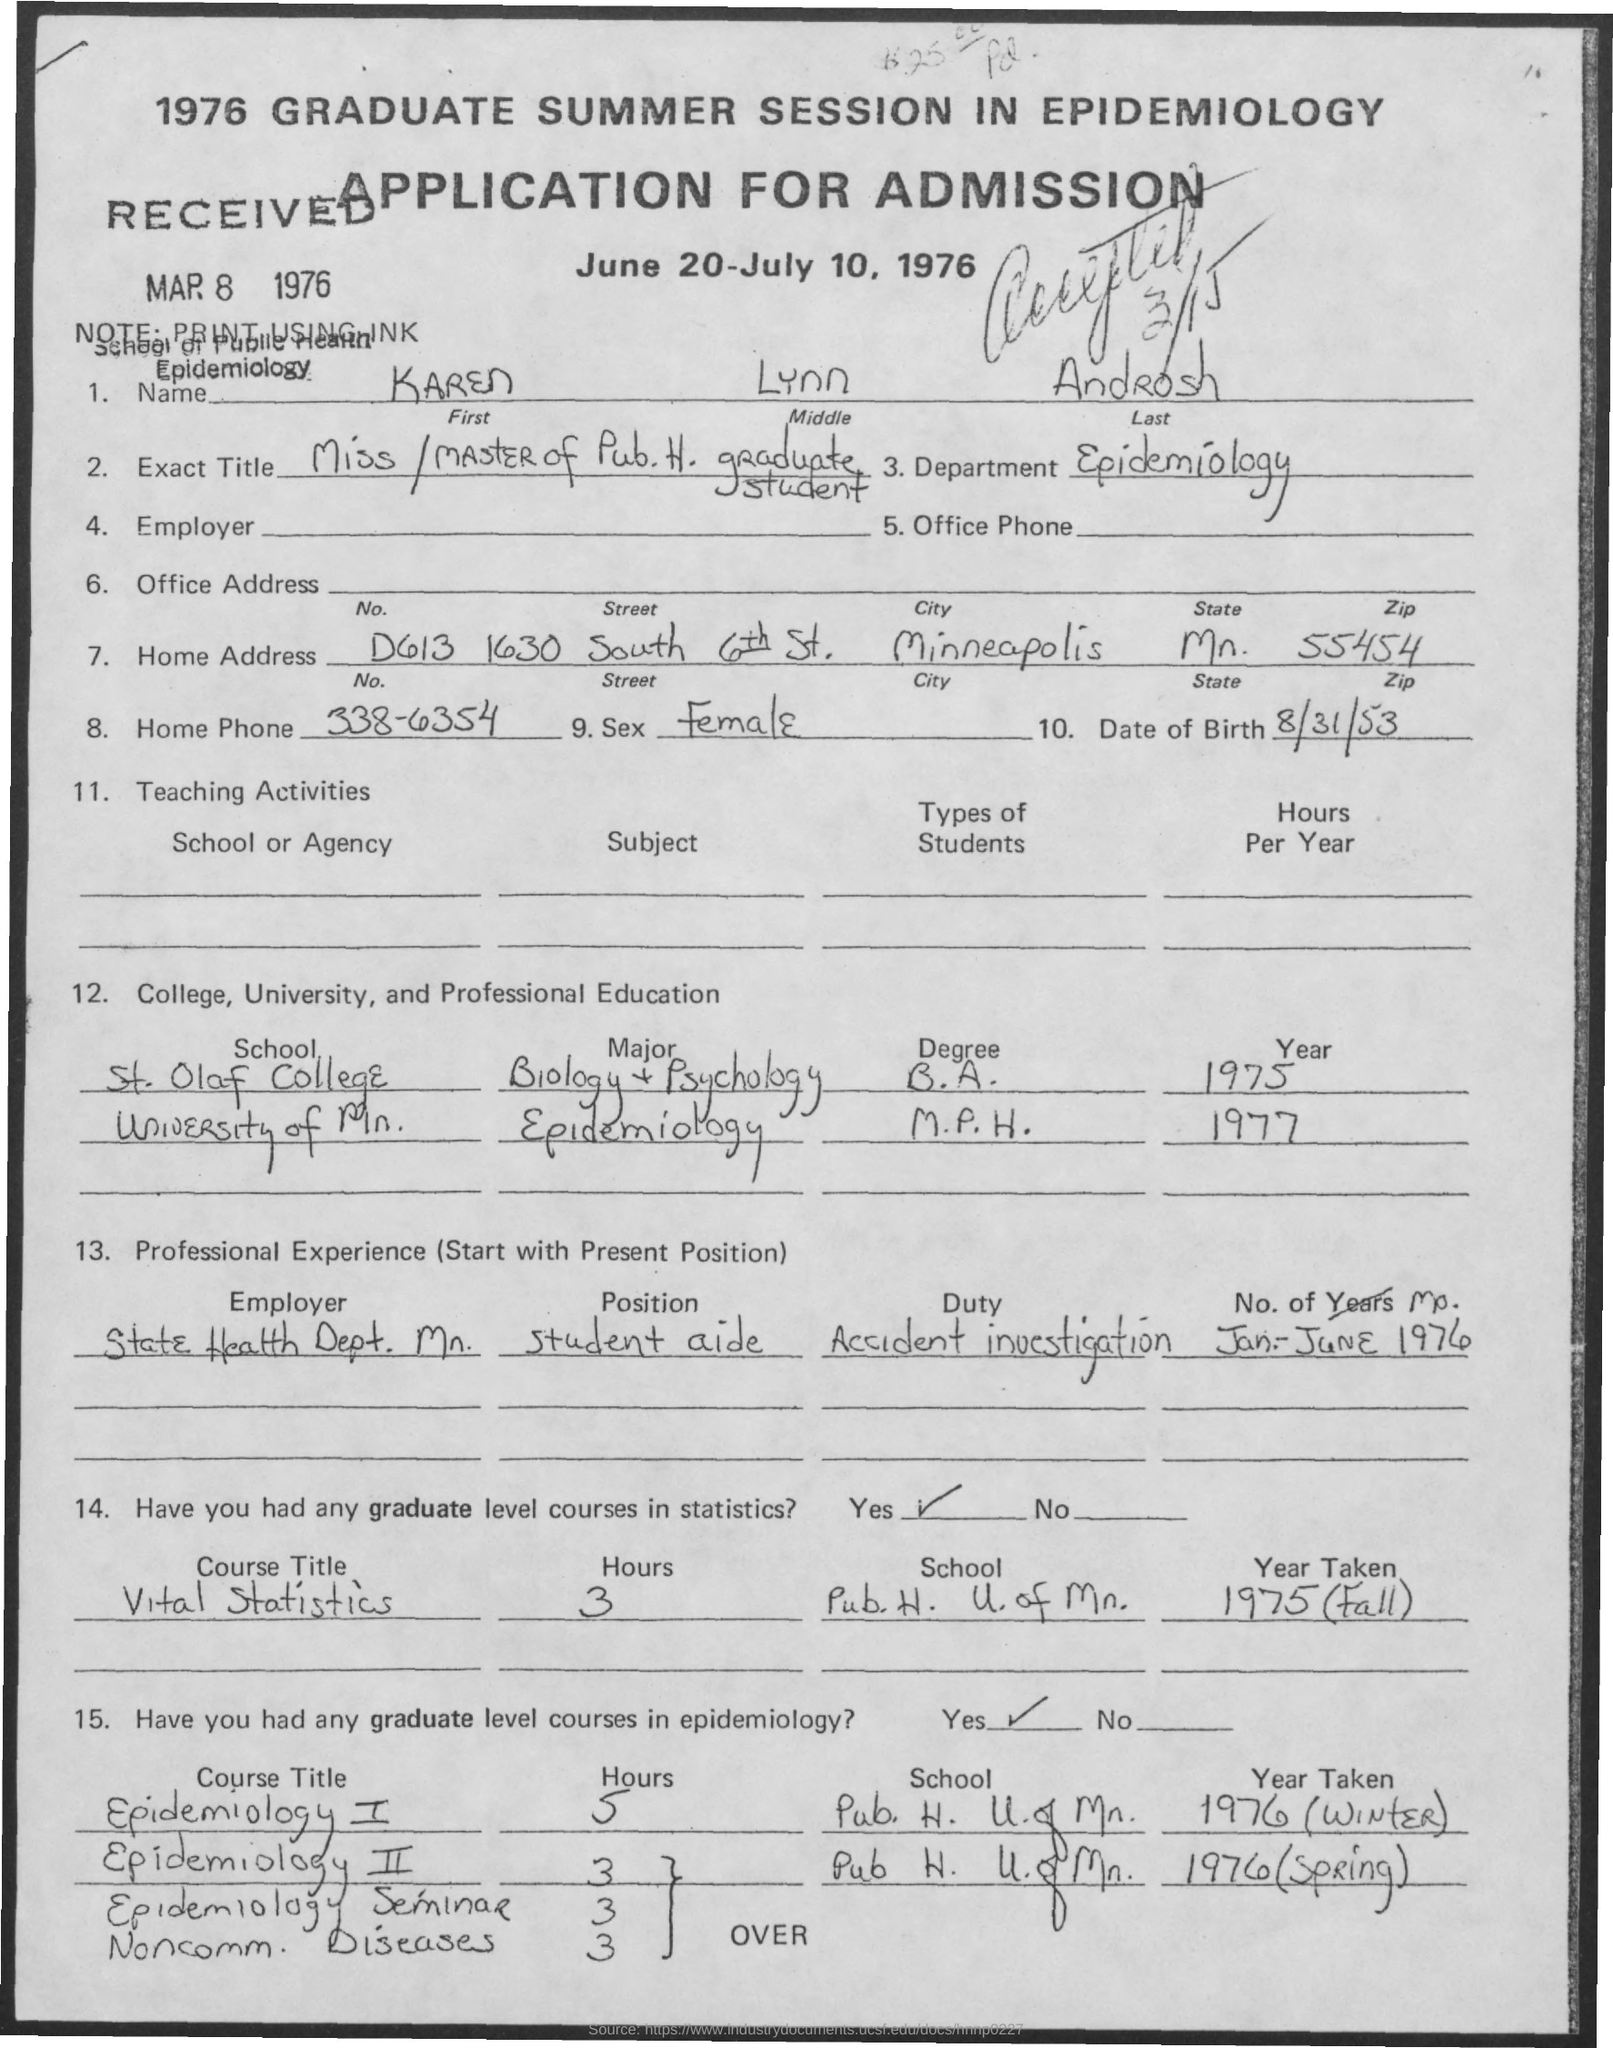Indicate a few pertinent items in this graphic. On August 31, 1953, Karen Lynn Androsh was born. The application indicates that the Epidemiology department is mentioned. The home phone number of Karen Lynn Androsh, as provided in the application, is 338-6354. The home address of the application mentions a city, and that city is Minneapolis. Karen Lynn Androsh completed her M.P.H. degree in Epidemiology in 1977. 